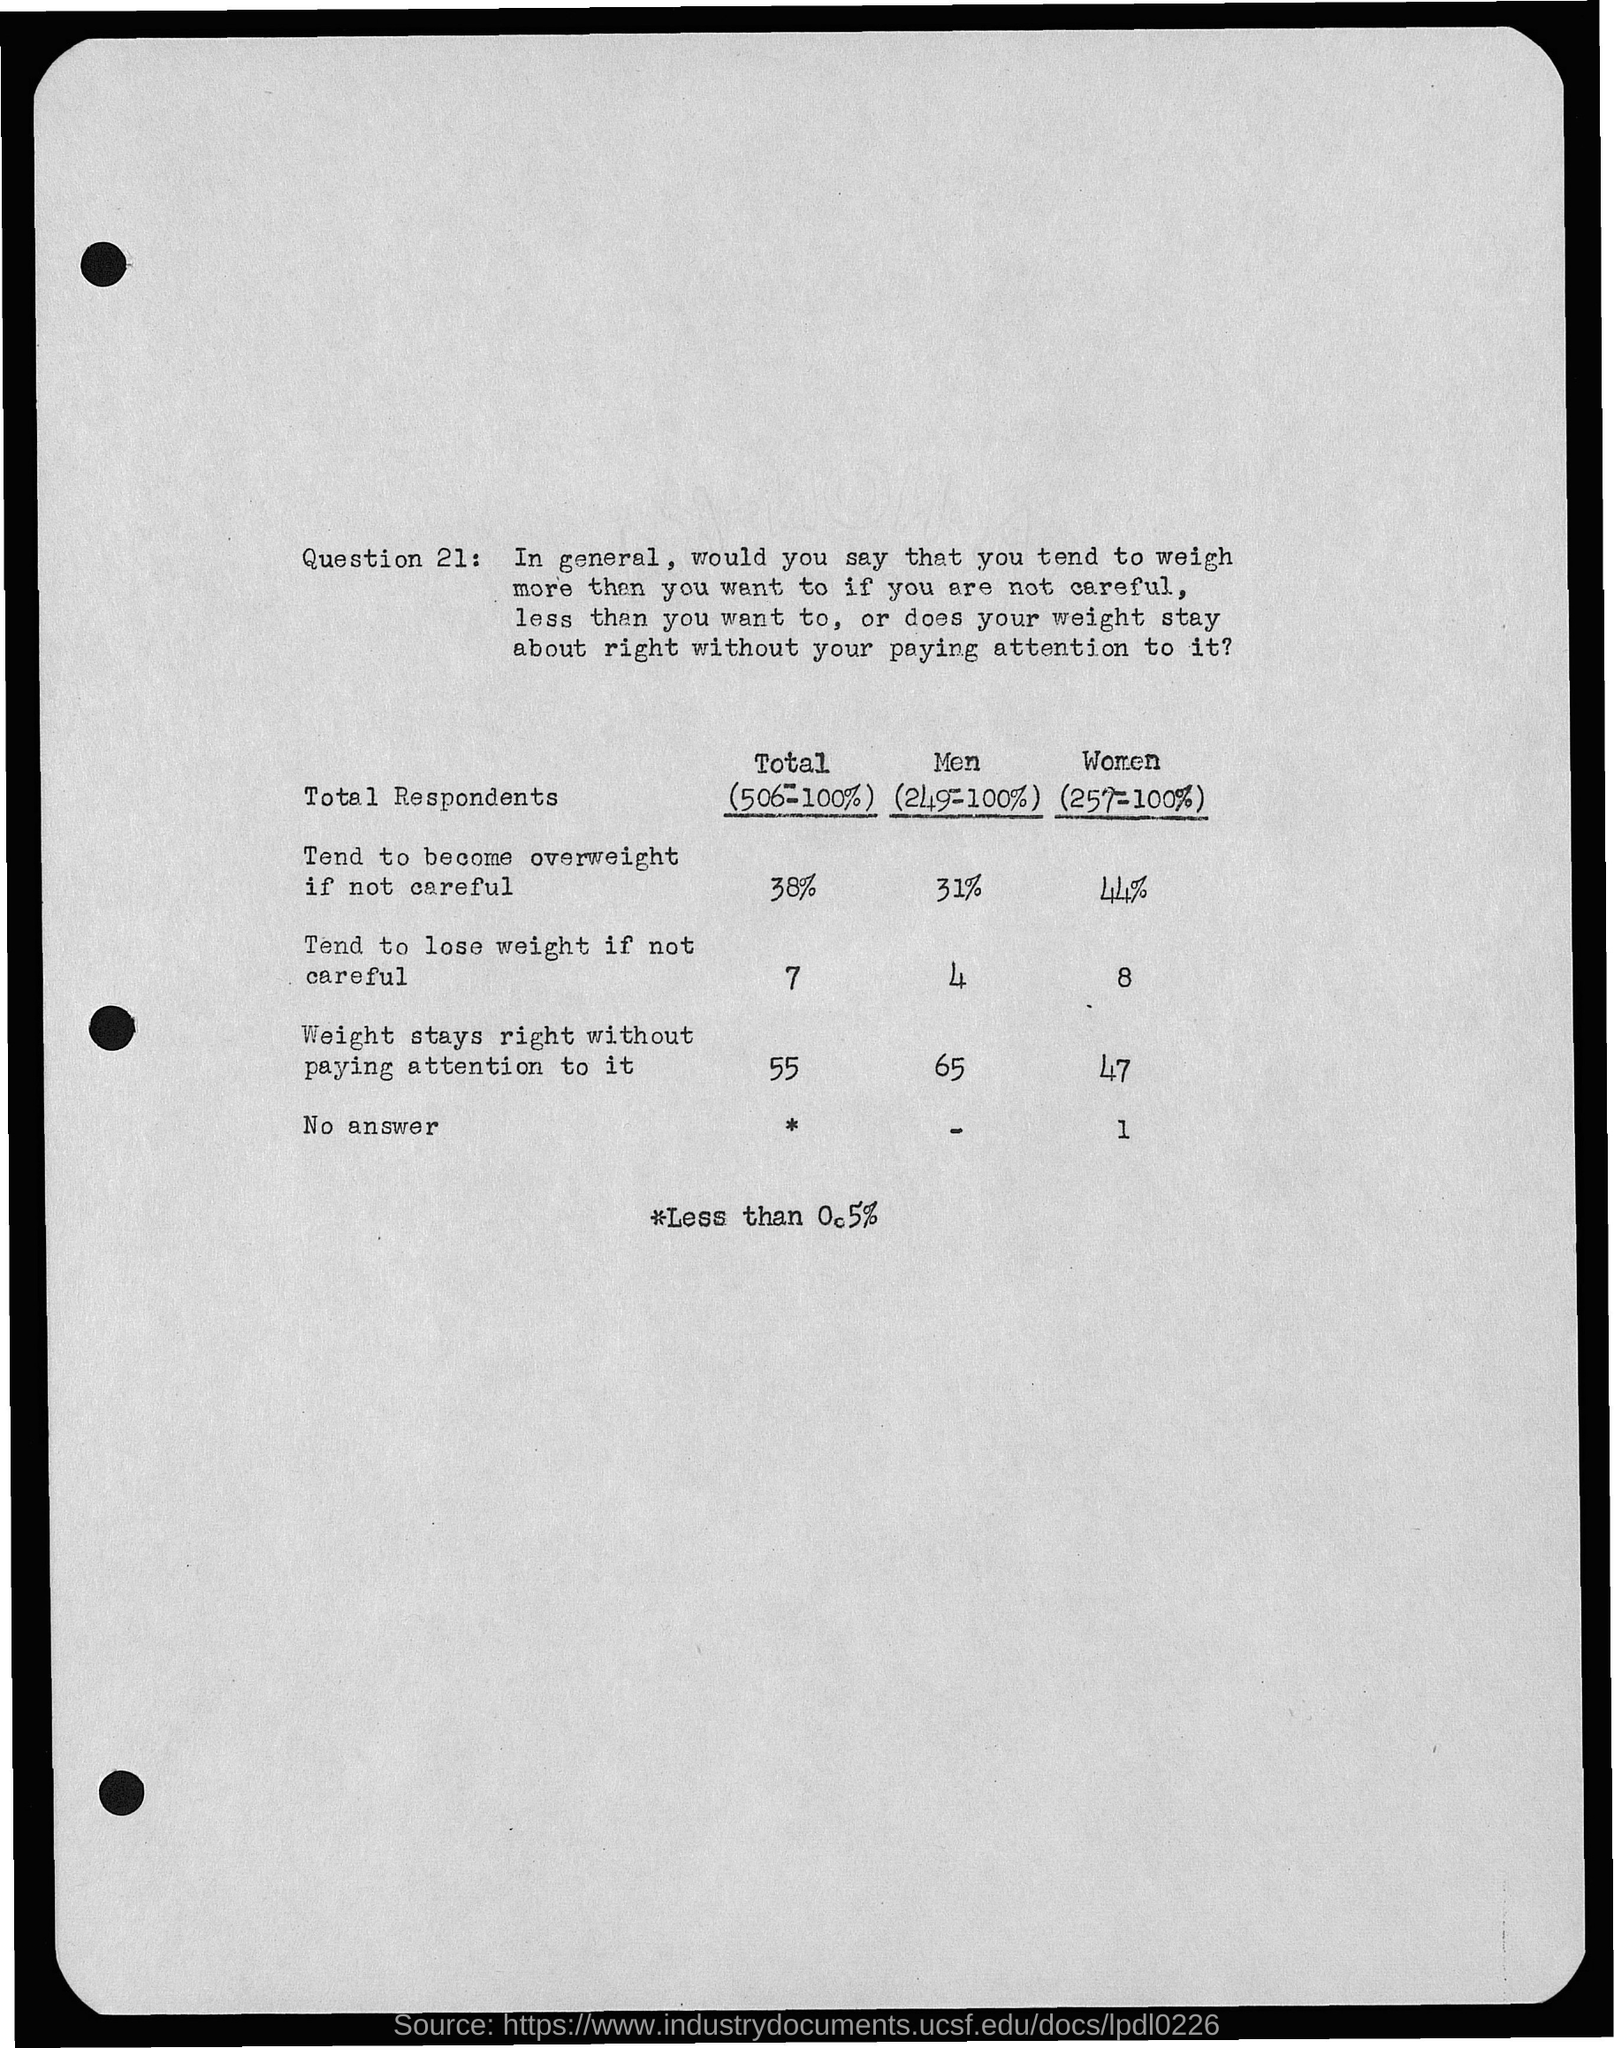Draw attention to some important aspects in this diagram. A significant portion, or 38%, of individuals who are not mindful of their weight are at risk of becoming overweight. It is possible for a total of 55 to maintain its weight without paying much attention to it. It is important to be mindful of the potential for weight loss if one is not careful, as approximately 7% of individuals who follow low-carb diets tend to lose weight rapidly and unintentionally. 